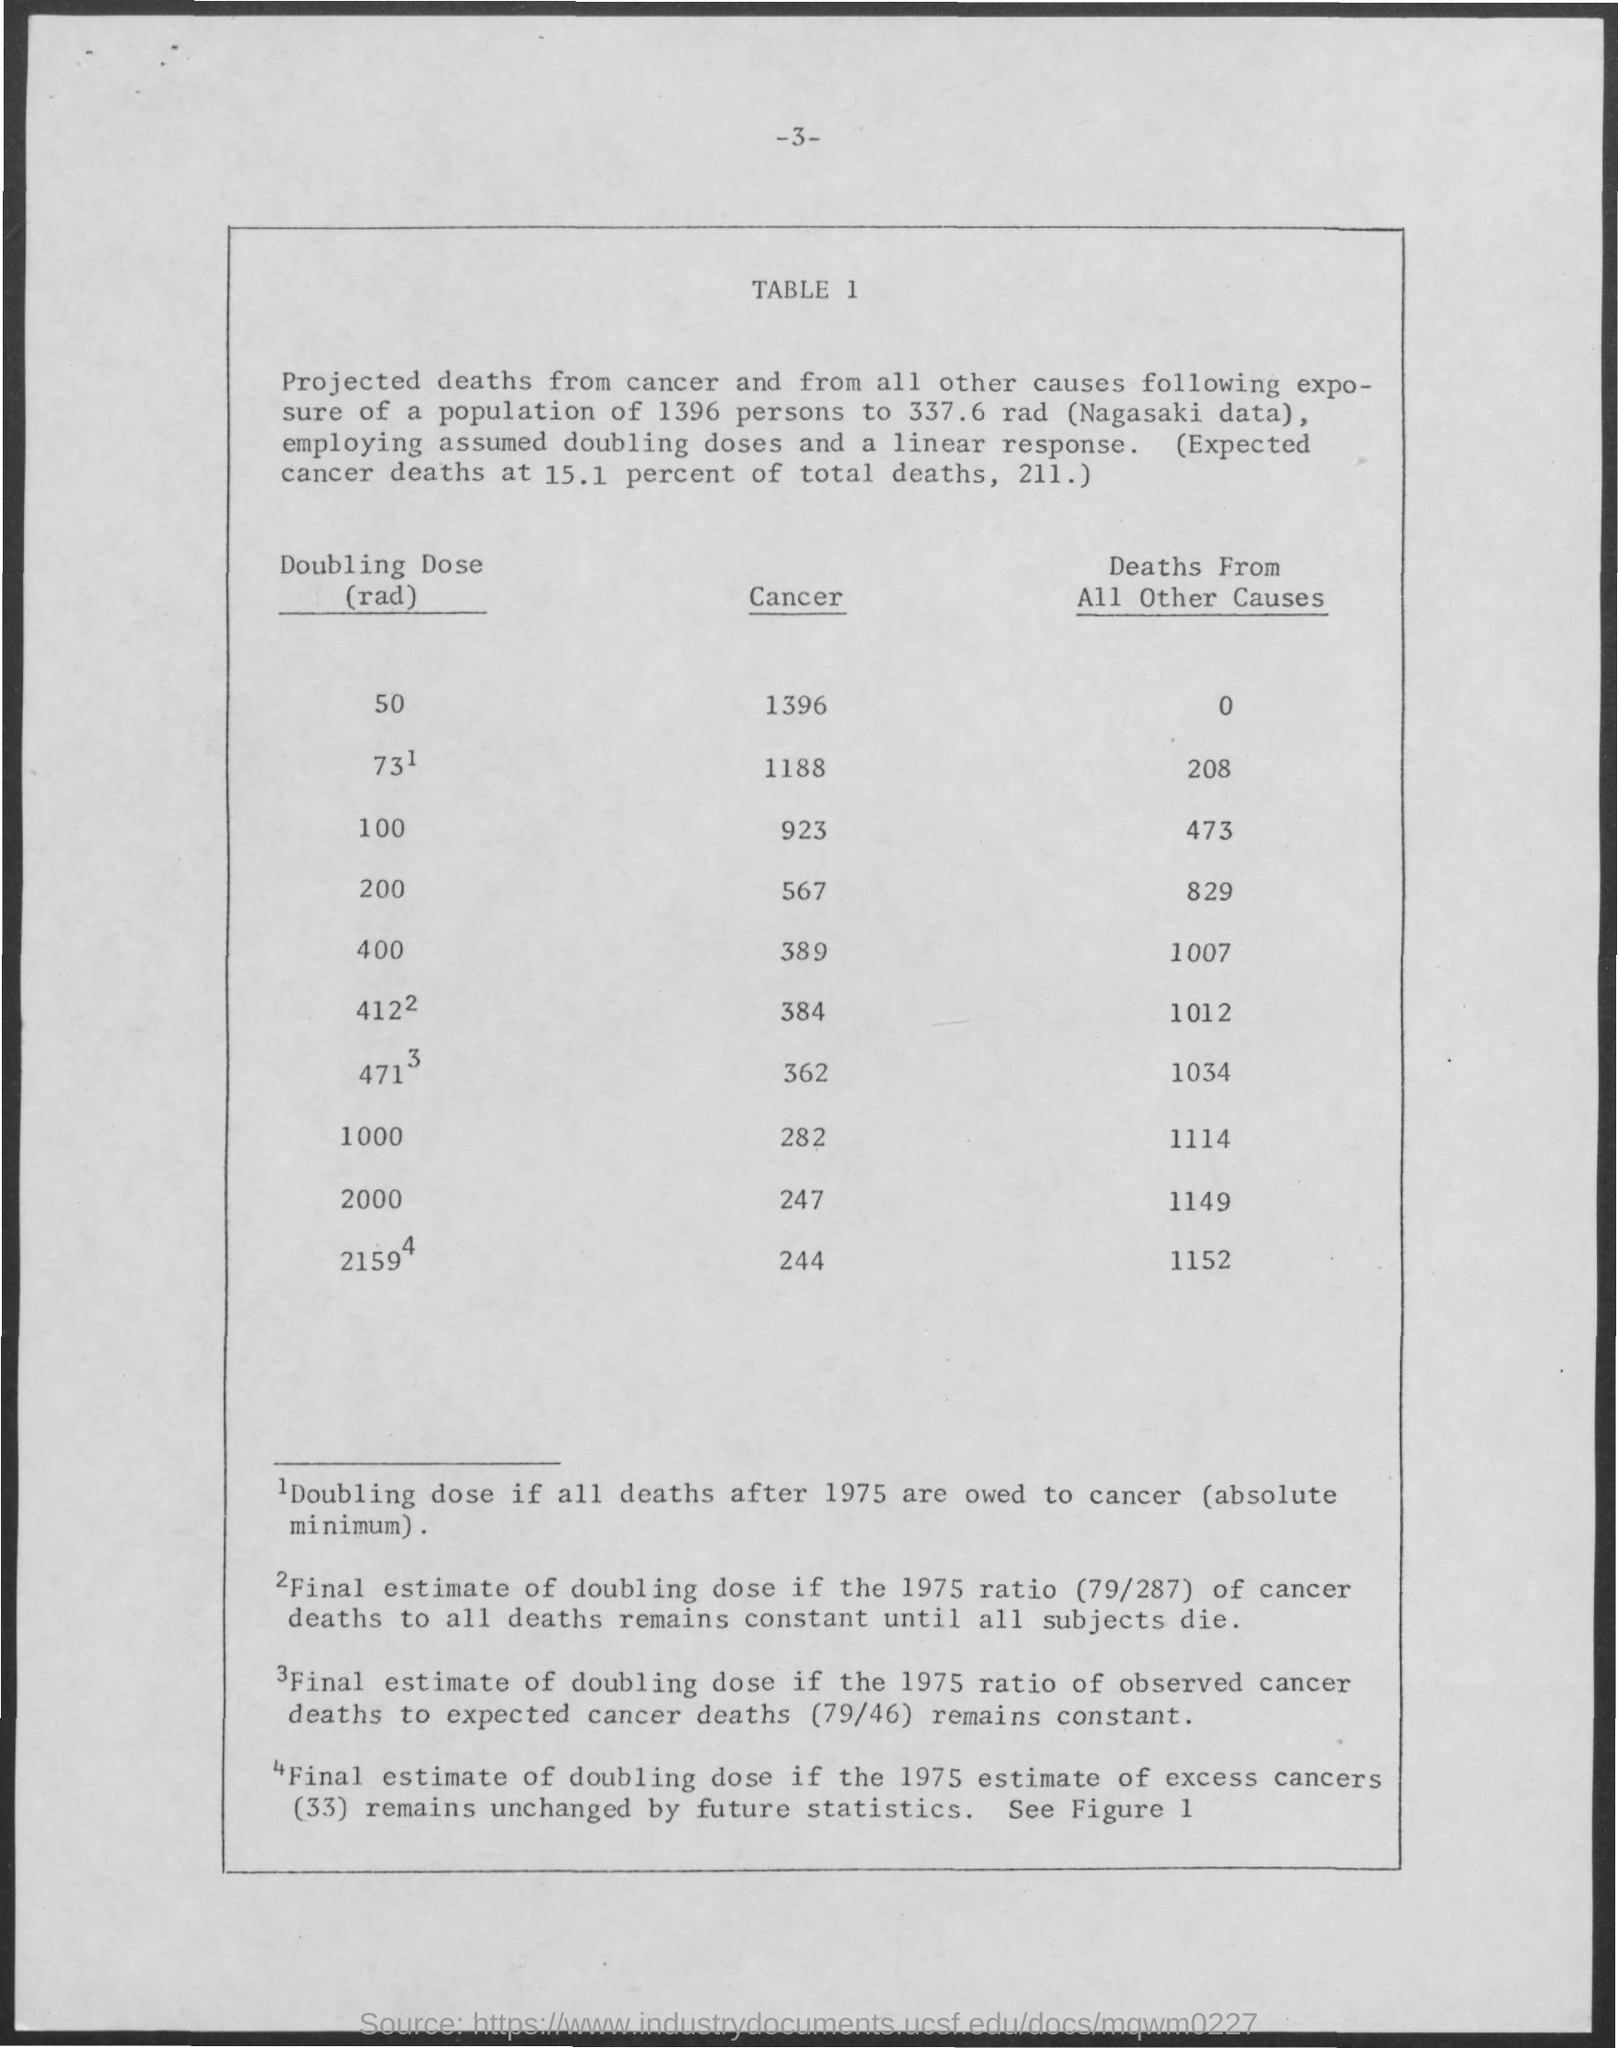Indicate a few pertinent items in this graphic. The estimated number of deaths from all other causes for a doubling dose of 100 rad is projected to be 473. The heading of the first column in the TABLE is "Doubling Dose(rad).." which is a declaration that states the increasing dosage of radiation being tested in the experiment. The number of projected deaths from cancer for a doubling dose of 2000 rad is 247. The page number written at the top of the page is 3, The heading of the third column of the TABLE is "Deaths From All Other Causes. 